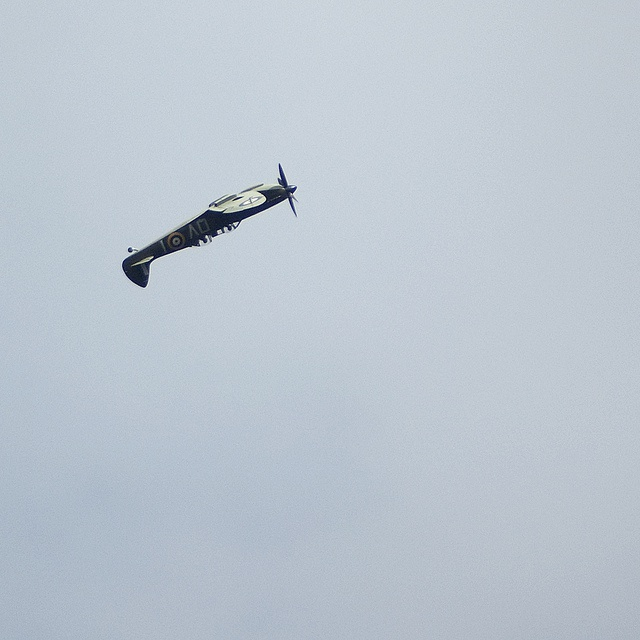Describe the objects in this image and their specific colors. I can see a airplane in lightgray, black, navy, beige, and gray tones in this image. 